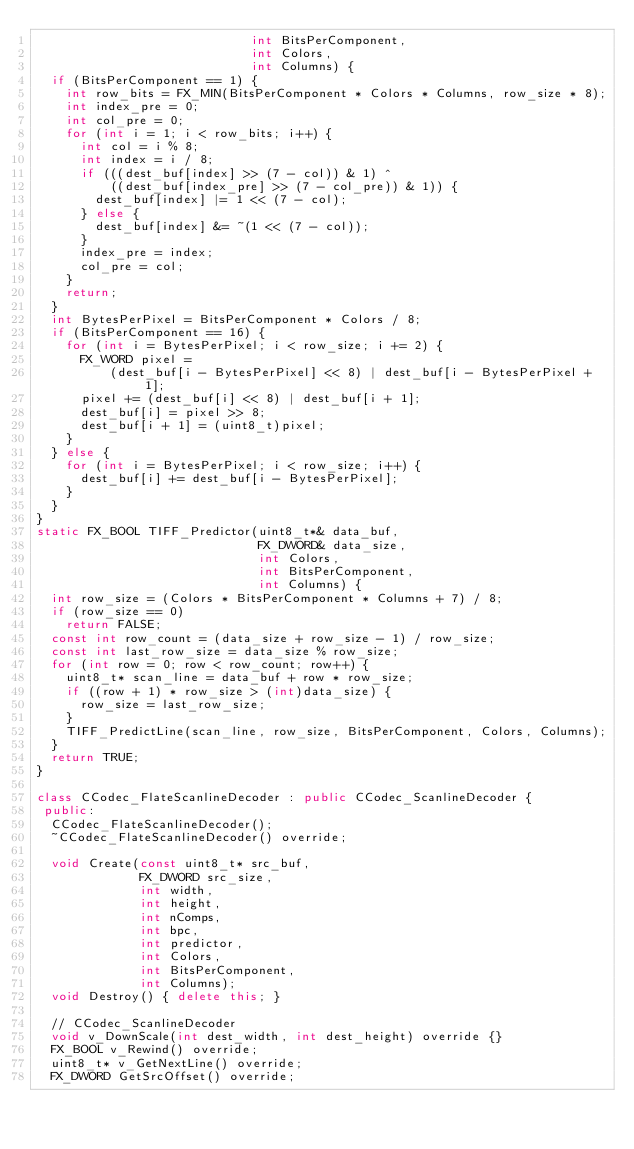Convert code to text. <code><loc_0><loc_0><loc_500><loc_500><_C++_>                             int BitsPerComponent,
                             int Colors,
                             int Columns) {
  if (BitsPerComponent == 1) {
    int row_bits = FX_MIN(BitsPerComponent * Colors * Columns, row_size * 8);
    int index_pre = 0;
    int col_pre = 0;
    for (int i = 1; i < row_bits; i++) {
      int col = i % 8;
      int index = i / 8;
      if (((dest_buf[index] >> (7 - col)) & 1) ^
          ((dest_buf[index_pre] >> (7 - col_pre)) & 1)) {
        dest_buf[index] |= 1 << (7 - col);
      } else {
        dest_buf[index] &= ~(1 << (7 - col));
      }
      index_pre = index;
      col_pre = col;
    }
    return;
  }
  int BytesPerPixel = BitsPerComponent * Colors / 8;
  if (BitsPerComponent == 16) {
    for (int i = BytesPerPixel; i < row_size; i += 2) {
      FX_WORD pixel =
          (dest_buf[i - BytesPerPixel] << 8) | dest_buf[i - BytesPerPixel + 1];
      pixel += (dest_buf[i] << 8) | dest_buf[i + 1];
      dest_buf[i] = pixel >> 8;
      dest_buf[i + 1] = (uint8_t)pixel;
    }
  } else {
    for (int i = BytesPerPixel; i < row_size; i++) {
      dest_buf[i] += dest_buf[i - BytesPerPixel];
    }
  }
}
static FX_BOOL TIFF_Predictor(uint8_t*& data_buf,
                              FX_DWORD& data_size,
                              int Colors,
                              int BitsPerComponent,
                              int Columns) {
  int row_size = (Colors * BitsPerComponent * Columns + 7) / 8;
  if (row_size == 0)
    return FALSE;
  const int row_count = (data_size + row_size - 1) / row_size;
  const int last_row_size = data_size % row_size;
  for (int row = 0; row < row_count; row++) {
    uint8_t* scan_line = data_buf + row * row_size;
    if ((row + 1) * row_size > (int)data_size) {
      row_size = last_row_size;
    }
    TIFF_PredictLine(scan_line, row_size, BitsPerComponent, Colors, Columns);
  }
  return TRUE;
}

class CCodec_FlateScanlineDecoder : public CCodec_ScanlineDecoder {
 public:
  CCodec_FlateScanlineDecoder();
  ~CCodec_FlateScanlineDecoder() override;

  void Create(const uint8_t* src_buf,
              FX_DWORD src_size,
              int width,
              int height,
              int nComps,
              int bpc,
              int predictor,
              int Colors,
              int BitsPerComponent,
              int Columns);
  void Destroy() { delete this; }

  // CCodec_ScanlineDecoder
  void v_DownScale(int dest_width, int dest_height) override {}
  FX_BOOL v_Rewind() override;
  uint8_t* v_GetNextLine() override;
  FX_DWORD GetSrcOffset() override;
</code> 